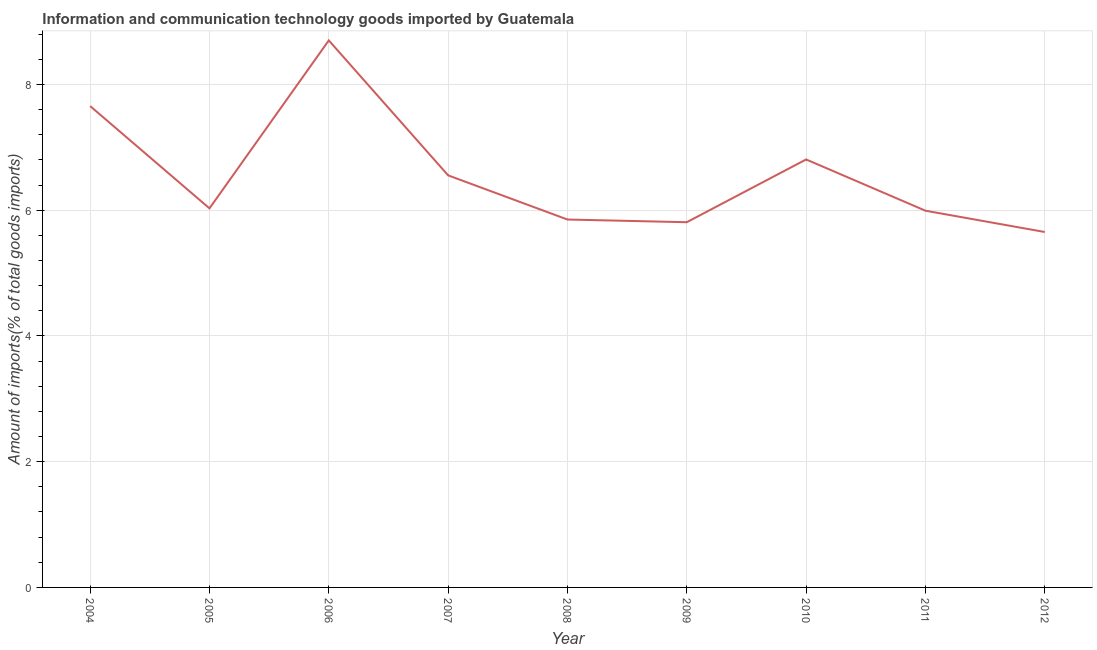What is the amount of ict goods imports in 2007?
Offer a terse response. 6.55. Across all years, what is the maximum amount of ict goods imports?
Offer a terse response. 8.7. Across all years, what is the minimum amount of ict goods imports?
Make the answer very short. 5.65. In which year was the amount of ict goods imports minimum?
Provide a short and direct response. 2012. What is the sum of the amount of ict goods imports?
Provide a short and direct response. 59.05. What is the difference between the amount of ict goods imports in 2006 and 2012?
Your response must be concise. 3.05. What is the average amount of ict goods imports per year?
Offer a very short reply. 6.56. What is the median amount of ict goods imports?
Your answer should be compact. 6.03. Do a majority of the years between 2011 and 2004 (inclusive) have amount of ict goods imports greater than 3.6 %?
Give a very brief answer. Yes. What is the ratio of the amount of ict goods imports in 2009 to that in 2012?
Give a very brief answer. 1.03. Is the difference between the amount of ict goods imports in 2006 and 2011 greater than the difference between any two years?
Provide a short and direct response. No. What is the difference between the highest and the second highest amount of ict goods imports?
Ensure brevity in your answer.  1.04. What is the difference between the highest and the lowest amount of ict goods imports?
Your answer should be compact. 3.05. In how many years, is the amount of ict goods imports greater than the average amount of ict goods imports taken over all years?
Offer a terse response. 3. Does the amount of ict goods imports monotonically increase over the years?
Keep it short and to the point. No. How many years are there in the graph?
Provide a succinct answer. 9. What is the difference between two consecutive major ticks on the Y-axis?
Offer a terse response. 2. Are the values on the major ticks of Y-axis written in scientific E-notation?
Offer a terse response. No. Does the graph contain grids?
Keep it short and to the point. Yes. What is the title of the graph?
Your answer should be very brief. Information and communication technology goods imported by Guatemala. What is the label or title of the X-axis?
Your answer should be very brief. Year. What is the label or title of the Y-axis?
Your answer should be very brief. Amount of imports(% of total goods imports). What is the Amount of imports(% of total goods imports) in 2004?
Your response must be concise. 7.66. What is the Amount of imports(% of total goods imports) in 2005?
Make the answer very short. 6.03. What is the Amount of imports(% of total goods imports) of 2006?
Offer a very short reply. 8.7. What is the Amount of imports(% of total goods imports) of 2007?
Give a very brief answer. 6.55. What is the Amount of imports(% of total goods imports) in 2008?
Make the answer very short. 5.85. What is the Amount of imports(% of total goods imports) in 2009?
Make the answer very short. 5.81. What is the Amount of imports(% of total goods imports) of 2010?
Make the answer very short. 6.81. What is the Amount of imports(% of total goods imports) in 2011?
Provide a succinct answer. 5.99. What is the Amount of imports(% of total goods imports) in 2012?
Offer a very short reply. 5.65. What is the difference between the Amount of imports(% of total goods imports) in 2004 and 2005?
Make the answer very short. 1.63. What is the difference between the Amount of imports(% of total goods imports) in 2004 and 2006?
Give a very brief answer. -1.04. What is the difference between the Amount of imports(% of total goods imports) in 2004 and 2007?
Make the answer very short. 1.1. What is the difference between the Amount of imports(% of total goods imports) in 2004 and 2008?
Provide a short and direct response. 1.8. What is the difference between the Amount of imports(% of total goods imports) in 2004 and 2009?
Provide a short and direct response. 1.85. What is the difference between the Amount of imports(% of total goods imports) in 2004 and 2010?
Your answer should be very brief. 0.85. What is the difference between the Amount of imports(% of total goods imports) in 2004 and 2011?
Offer a terse response. 1.66. What is the difference between the Amount of imports(% of total goods imports) in 2004 and 2012?
Offer a very short reply. 2. What is the difference between the Amount of imports(% of total goods imports) in 2005 and 2006?
Make the answer very short. -2.67. What is the difference between the Amount of imports(% of total goods imports) in 2005 and 2007?
Provide a succinct answer. -0.53. What is the difference between the Amount of imports(% of total goods imports) in 2005 and 2008?
Keep it short and to the point. 0.18. What is the difference between the Amount of imports(% of total goods imports) in 2005 and 2009?
Keep it short and to the point. 0.22. What is the difference between the Amount of imports(% of total goods imports) in 2005 and 2010?
Provide a short and direct response. -0.78. What is the difference between the Amount of imports(% of total goods imports) in 2005 and 2011?
Provide a succinct answer. 0.04. What is the difference between the Amount of imports(% of total goods imports) in 2005 and 2012?
Your answer should be compact. 0.38. What is the difference between the Amount of imports(% of total goods imports) in 2006 and 2007?
Ensure brevity in your answer.  2.15. What is the difference between the Amount of imports(% of total goods imports) in 2006 and 2008?
Your response must be concise. 2.85. What is the difference between the Amount of imports(% of total goods imports) in 2006 and 2009?
Your answer should be very brief. 2.89. What is the difference between the Amount of imports(% of total goods imports) in 2006 and 2010?
Your answer should be very brief. 1.89. What is the difference between the Amount of imports(% of total goods imports) in 2006 and 2011?
Ensure brevity in your answer.  2.71. What is the difference between the Amount of imports(% of total goods imports) in 2006 and 2012?
Offer a terse response. 3.05. What is the difference between the Amount of imports(% of total goods imports) in 2007 and 2008?
Keep it short and to the point. 0.7. What is the difference between the Amount of imports(% of total goods imports) in 2007 and 2009?
Offer a terse response. 0.75. What is the difference between the Amount of imports(% of total goods imports) in 2007 and 2010?
Offer a very short reply. -0.25. What is the difference between the Amount of imports(% of total goods imports) in 2007 and 2011?
Provide a succinct answer. 0.56. What is the difference between the Amount of imports(% of total goods imports) in 2007 and 2012?
Your answer should be very brief. 0.9. What is the difference between the Amount of imports(% of total goods imports) in 2008 and 2009?
Provide a succinct answer. 0.04. What is the difference between the Amount of imports(% of total goods imports) in 2008 and 2010?
Give a very brief answer. -0.96. What is the difference between the Amount of imports(% of total goods imports) in 2008 and 2011?
Offer a very short reply. -0.14. What is the difference between the Amount of imports(% of total goods imports) in 2008 and 2012?
Your response must be concise. 0.2. What is the difference between the Amount of imports(% of total goods imports) in 2009 and 2010?
Provide a short and direct response. -1. What is the difference between the Amount of imports(% of total goods imports) in 2009 and 2011?
Offer a terse response. -0.18. What is the difference between the Amount of imports(% of total goods imports) in 2009 and 2012?
Provide a succinct answer. 0.16. What is the difference between the Amount of imports(% of total goods imports) in 2010 and 2011?
Your answer should be compact. 0.81. What is the difference between the Amount of imports(% of total goods imports) in 2010 and 2012?
Ensure brevity in your answer.  1.15. What is the difference between the Amount of imports(% of total goods imports) in 2011 and 2012?
Offer a terse response. 0.34. What is the ratio of the Amount of imports(% of total goods imports) in 2004 to that in 2005?
Provide a succinct answer. 1.27. What is the ratio of the Amount of imports(% of total goods imports) in 2004 to that in 2007?
Your answer should be compact. 1.17. What is the ratio of the Amount of imports(% of total goods imports) in 2004 to that in 2008?
Offer a terse response. 1.31. What is the ratio of the Amount of imports(% of total goods imports) in 2004 to that in 2009?
Provide a short and direct response. 1.32. What is the ratio of the Amount of imports(% of total goods imports) in 2004 to that in 2010?
Give a very brief answer. 1.12. What is the ratio of the Amount of imports(% of total goods imports) in 2004 to that in 2011?
Ensure brevity in your answer.  1.28. What is the ratio of the Amount of imports(% of total goods imports) in 2004 to that in 2012?
Offer a terse response. 1.35. What is the ratio of the Amount of imports(% of total goods imports) in 2005 to that in 2006?
Ensure brevity in your answer.  0.69. What is the ratio of the Amount of imports(% of total goods imports) in 2005 to that in 2009?
Offer a very short reply. 1.04. What is the ratio of the Amount of imports(% of total goods imports) in 2005 to that in 2010?
Make the answer very short. 0.89. What is the ratio of the Amount of imports(% of total goods imports) in 2005 to that in 2012?
Make the answer very short. 1.07. What is the ratio of the Amount of imports(% of total goods imports) in 2006 to that in 2007?
Provide a short and direct response. 1.33. What is the ratio of the Amount of imports(% of total goods imports) in 2006 to that in 2008?
Your response must be concise. 1.49. What is the ratio of the Amount of imports(% of total goods imports) in 2006 to that in 2009?
Your response must be concise. 1.5. What is the ratio of the Amount of imports(% of total goods imports) in 2006 to that in 2010?
Keep it short and to the point. 1.28. What is the ratio of the Amount of imports(% of total goods imports) in 2006 to that in 2011?
Your response must be concise. 1.45. What is the ratio of the Amount of imports(% of total goods imports) in 2006 to that in 2012?
Ensure brevity in your answer.  1.54. What is the ratio of the Amount of imports(% of total goods imports) in 2007 to that in 2008?
Offer a very short reply. 1.12. What is the ratio of the Amount of imports(% of total goods imports) in 2007 to that in 2009?
Make the answer very short. 1.13. What is the ratio of the Amount of imports(% of total goods imports) in 2007 to that in 2010?
Keep it short and to the point. 0.96. What is the ratio of the Amount of imports(% of total goods imports) in 2007 to that in 2011?
Provide a short and direct response. 1.09. What is the ratio of the Amount of imports(% of total goods imports) in 2007 to that in 2012?
Make the answer very short. 1.16. What is the ratio of the Amount of imports(% of total goods imports) in 2008 to that in 2009?
Keep it short and to the point. 1.01. What is the ratio of the Amount of imports(% of total goods imports) in 2008 to that in 2010?
Your answer should be very brief. 0.86. What is the ratio of the Amount of imports(% of total goods imports) in 2008 to that in 2012?
Your answer should be very brief. 1.03. What is the ratio of the Amount of imports(% of total goods imports) in 2009 to that in 2010?
Give a very brief answer. 0.85. What is the ratio of the Amount of imports(% of total goods imports) in 2009 to that in 2011?
Your answer should be very brief. 0.97. What is the ratio of the Amount of imports(% of total goods imports) in 2009 to that in 2012?
Offer a very short reply. 1.03. What is the ratio of the Amount of imports(% of total goods imports) in 2010 to that in 2011?
Provide a short and direct response. 1.14. What is the ratio of the Amount of imports(% of total goods imports) in 2010 to that in 2012?
Offer a very short reply. 1.2. What is the ratio of the Amount of imports(% of total goods imports) in 2011 to that in 2012?
Your answer should be compact. 1.06. 